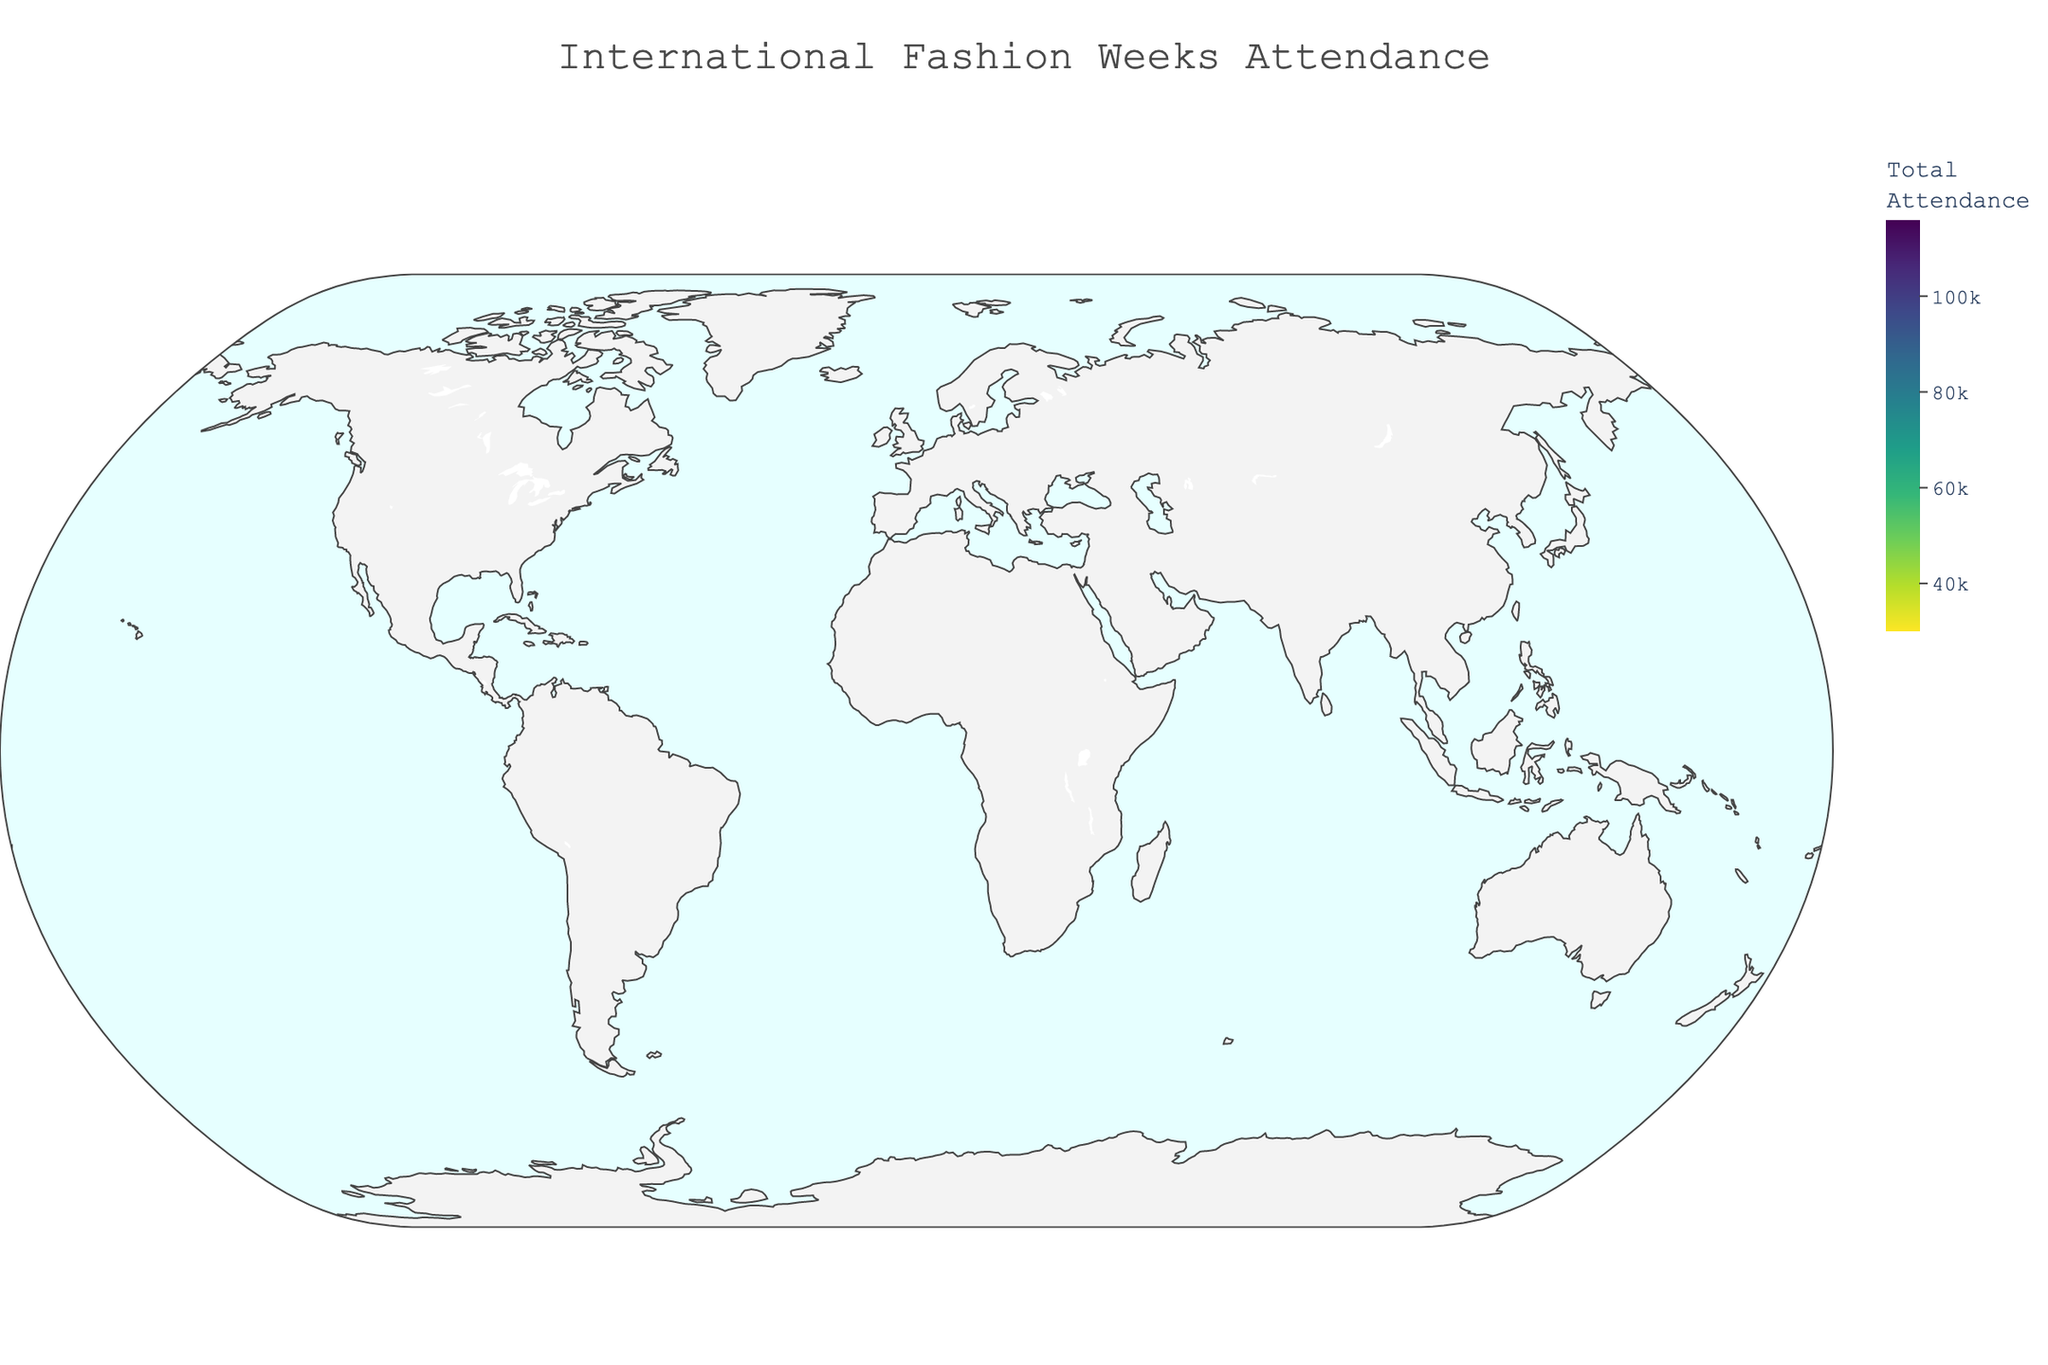What is the total attendance for the New York fashion week? The figure shows bubble sizes representing total attendance. Observing New York, the bubble size indicates 116,000 attendees.
Answer: 116,000 Which city has the lowest total attendance? By examining the bubble sizes across all cities, Shanghai has the smallest bubble, meaning it has the lowest total attendance of 30,000.
Answer: Shanghai How many more attendees were there in Paris compared to Milan? The total attendance in Paris is 105,000, and in Milan, it is 98,000. By subtracting Milan's attendance from Paris's attendance (105,000 - 98,000), there are 7,000 more attendees in Paris.
Answer: 7,000 Which city has more celebrities attending: Tokyo or London? According to the hover data, Tokyo has 1,000 celebrities while London has 1,200 celebrities. Therefore, London has more celebrities attending.
Answer: London What is the average number of designers attending all fashion weeks? Summing the number of designers from all cities (3500 + 3200 + 3000 + 2800 + 2500 + 2000 + 1800 + 1500 + 1200 + 1000) equals 24,500. Dividing by the total number of cities (10), the average number of designers is 24,500 / 10 = 2,450.
Answer: 2,450 Which city has the highest number of buyers? By inspecting the hover data for buyers, New York has the highest number of buyers with 42,000.
Answer: New York What is the total number of "Other Industry Professionals" across all cities? Adding "Other Industry Professionals" for each city (64,000 + 57,000 + 53,700 + 47,000 + 38,000 + 29,200 + 24,000 + 21,900 + 19,500 + 17,100) gives a total of 371,400.
Answer: 371,400 How does the attendance of Berlin's fashion week compare to Sydney's? Considering the total attendance, Berlin has 55,000 attendees while Sydney has 45,000 attendees. Therefore, Berlin has 10,000 more attendees than Sydney.
Answer: 10,000 more What is the total number of media professionals attending the top three cities (by attendance)? The top three cities by attendance are New York, Paris, and Milan. The number of media professionals in these cities is 5,000 (New York) + 4,800 (Paris) + 4,500 (Milan). Summing these, the total is 5,000 + 4,800 + 4,500 = 14,300.
Answer: 14,300 